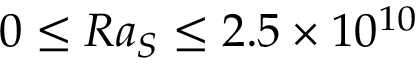Convert formula to latex. <formula><loc_0><loc_0><loc_500><loc_500>0 \leq R a _ { S } \leq 2 . 5 \times 1 0 ^ { 1 0 }</formula> 